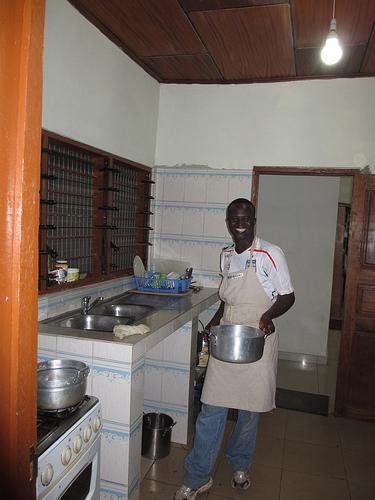How many people are there?
Give a very brief answer. 1. 